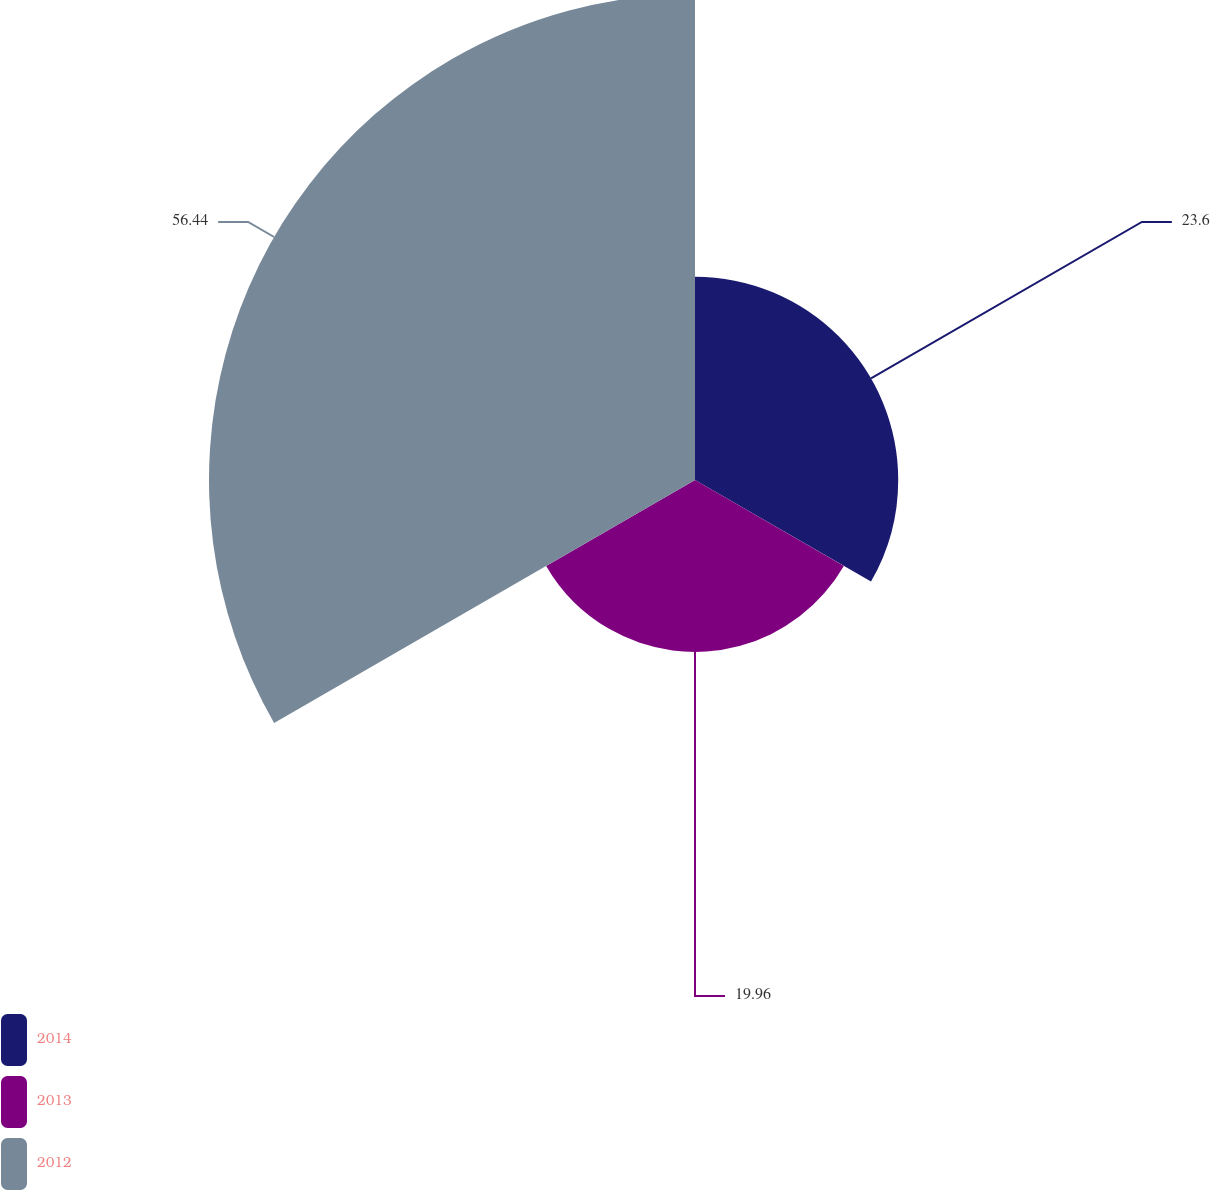Convert chart to OTSL. <chart><loc_0><loc_0><loc_500><loc_500><pie_chart><fcel>2014<fcel>2013<fcel>2012<nl><fcel>23.6%<fcel>19.96%<fcel>56.44%<nl></chart> 